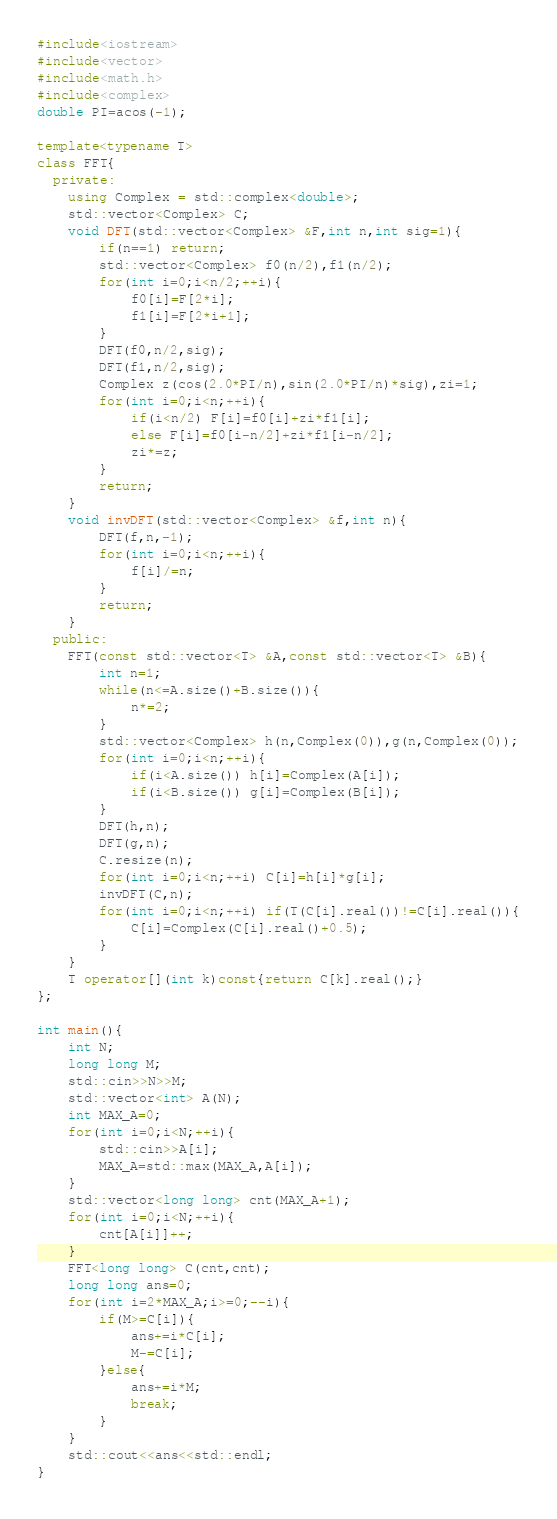Convert code to text. <code><loc_0><loc_0><loc_500><loc_500><_C++_>#include<iostream>
#include<vector>
#include<math.h>
#include<complex>
double PI=acos(-1);

template<typename T>
class FFT{
  private:
    using Complex = std::complex<double>;
    std::vector<Complex> C;
    void DFT(std::vector<Complex> &F,int n,int sig=1){
        if(n==1) return;
        std::vector<Complex> f0(n/2),f1(n/2);
        for(int i=0;i<n/2;++i){
            f0[i]=F[2*i];
            f1[i]=F[2*i+1];
        }
        DFT(f0,n/2,sig);
        DFT(f1,n/2,sig);
        Complex z(cos(2.0*PI/n),sin(2.0*PI/n)*sig),zi=1;
        for(int i=0;i<n;++i){
            if(i<n/2) F[i]=f0[i]+zi*f1[i];
            else F[i]=f0[i-n/2]+zi*f1[i-n/2];
            zi*=z;
        }
        return;
    }
    void invDFT(std::vector<Complex> &f,int n){
        DFT(f,n,-1);
        for(int i=0;i<n;++i){
            f[i]/=n;
        }
        return;
    }
  public:
    FFT(const std::vector<T> &A,const std::vector<T> &B){
        int n=1;
        while(n<=A.size()+B.size()){
            n*=2;
        }
        std::vector<Complex> h(n,Complex(0)),g(n,Complex(0));
        for(int i=0;i<n;++i){
            if(i<A.size()) h[i]=Complex(A[i]);
            if(i<B.size()) g[i]=Complex(B[i]);
        }
        DFT(h,n);
        DFT(g,n);
        C.resize(n);
        for(int i=0;i<n;++i) C[i]=h[i]*g[i];
        invDFT(C,n);
        for(int i=0;i<n;++i) if(T(C[i].real())!=C[i].real()){
            C[i]=Complex(C[i].real()+0.5);
        }
    }
    T operator[](int k)const{return C[k].real();}
};

int main(){
    int N;
    long long M;
    std::cin>>N>>M;
    std::vector<int> A(N);
    int MAX_A=0;
    for(int i=0;i<N;++i){
        std::cin>>A[i];
        MAX_A=std::max(MAX_A,A[i]);
    }
    std::vector<long long> cnt(MAX_A+1);
    for(int i=0;i<N;++i){
        cnt[A[i]]++;
    }
    FFT<long long> C(cnt,cnt);
    long long ans=0;
    for(int i=2*MAX_A;i>=0;--i){
        if(M>=C[i]){
            ans+=i*C[i];
            M-=C[i];
        }else{
            ans+=i*M;
            break;
        }
    }
    std::cout<<ans<<std::endl;
}</code> 